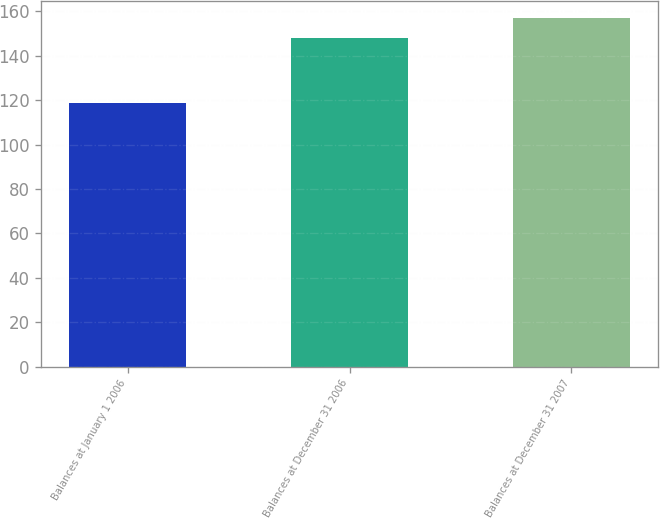Convert chart. <chart><loc_0><loc_0><loc_500><loc_500><bar_chart><fcel>Balances at January 1 2006<fcel>Balances at December 31 2006<fcel>Balances at December 31 2007<nl><fcel>118.7<fcel>147.8<fcel>156.9<nl></chart> 